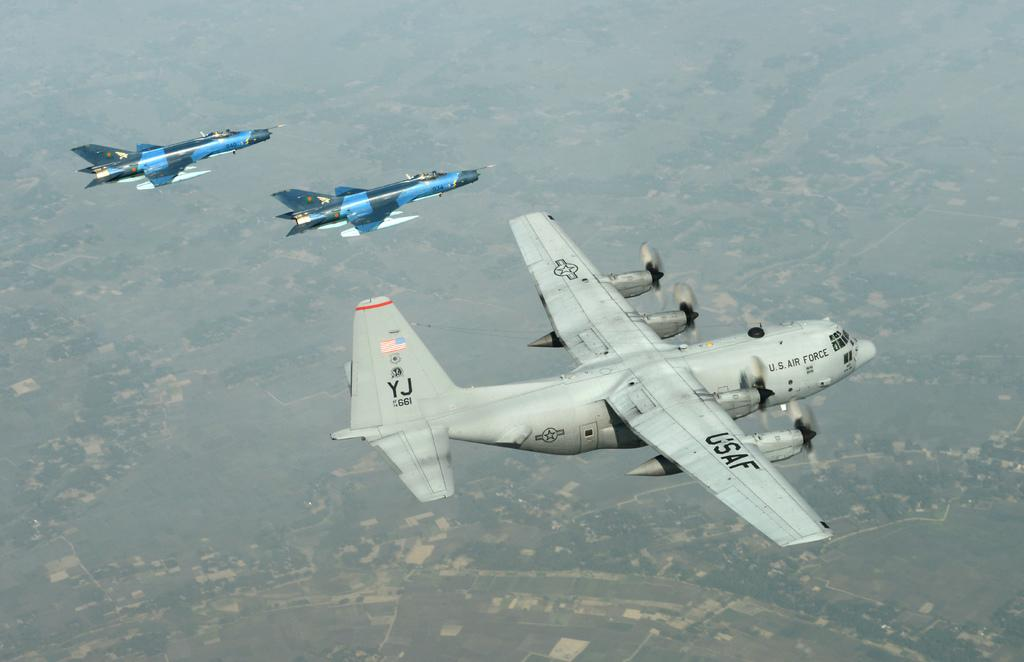<image>
Summarize the visual content of the image. A large usaf airplane in mid flight with a smaller blue jet by its side. 